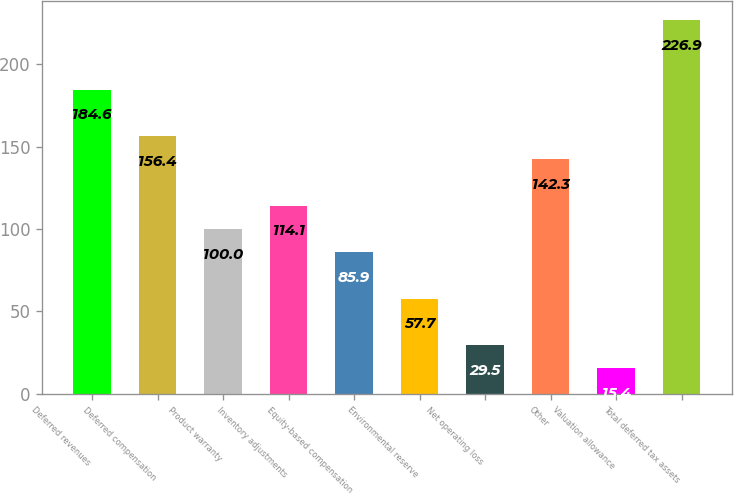<chart> <loc_0><loc_0><loc_500><loc_500><bar_chart><fcel>Deferred revenues<fcel>Deferred compensation<fcel>Product warranty<fcel>Inventory adjustments<fcel>Equity-based compensation<fcel>Environmental reserve<fcel>Net operating loss<fcel>Other<fcel>Valuation allowance<fcel>Total deferred tax assets<nl><fcel>184.6<fcel>156.4<fcel>100<fcel>114.1<fcel>85.9<fcel>57.7<fcel>29.5<fcel>142.3<fcel>15.4<fcel>226.9<nl></chart> 